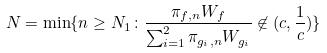Convert formula to latex. <formula><loc_0><loc_0><loc_500><loc_500>N = \min \{ n \geq N _ { 1 } \colon \frac { \pi _ { f , n } W _ { f } } { \sum _ { i = 1 } ^ { 2 } \pi _ { g _ { i } , n } W _ { g _ { i } } } \not \in ( c , \frac { 1 } { c } ) \}</formula> 